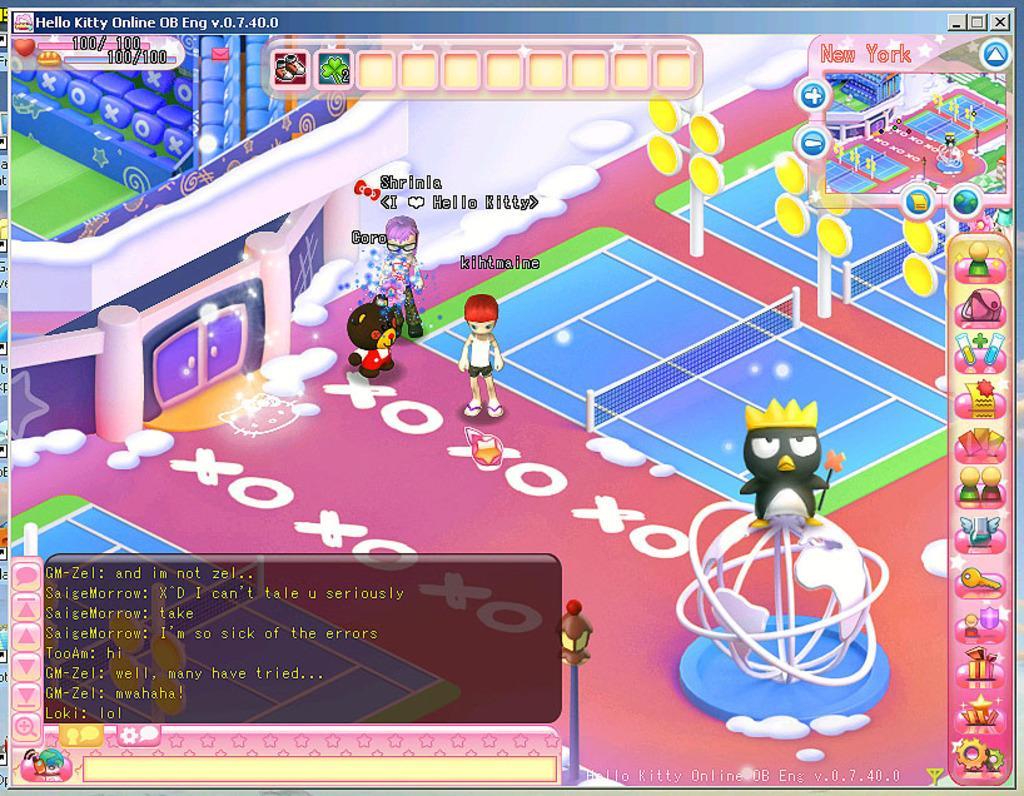Describe this image in one or two sentences. This picture shows a game and we see cartoons and text on it. 